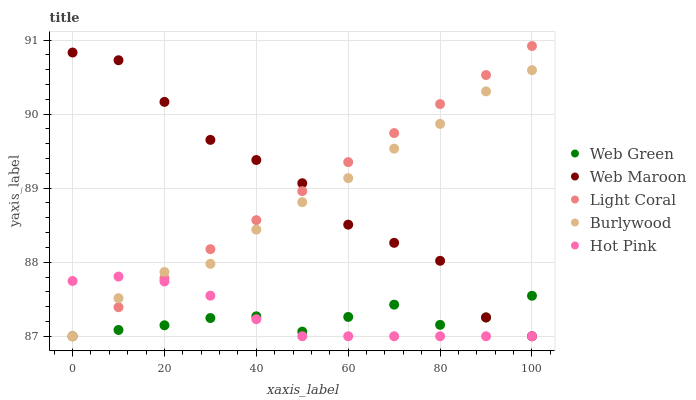Does Web Green have the minimum area under the curve?
Answer yes or no. Yes. Does Web Maroon have the maximum area under the curve?
Answer yes or no. Yes. Does Burlywood have the minimum area under the curve?
Answer yes or no. No. Does Burlywood have the maximum area under the curve?
Answer yes or no. No. Is Light Coral the smoothest?
Answer yes or no. Yes. Is Web Maroon the roughest?
Answer yes or no. Yes. Is Burlywood the smoothest?
Answer yes or no. No. Is Burlywood the roughest?
Answer yes or no. No. Does Light Coral have the lowest value?
Answer yes or no. Yes. Does Light Coral have the highest value?
Answer yes or no. Yes. Does Burlywood have the highest value?
Answer yes or no. No. Does Burlywood intersect Hot Pink?
Answer yes or no. Yes. Is Burlywood less than Hot Pink?
Answer yes or no. No. Is Burlywood greater than Hot Pink?
Answer yes or no. No. 